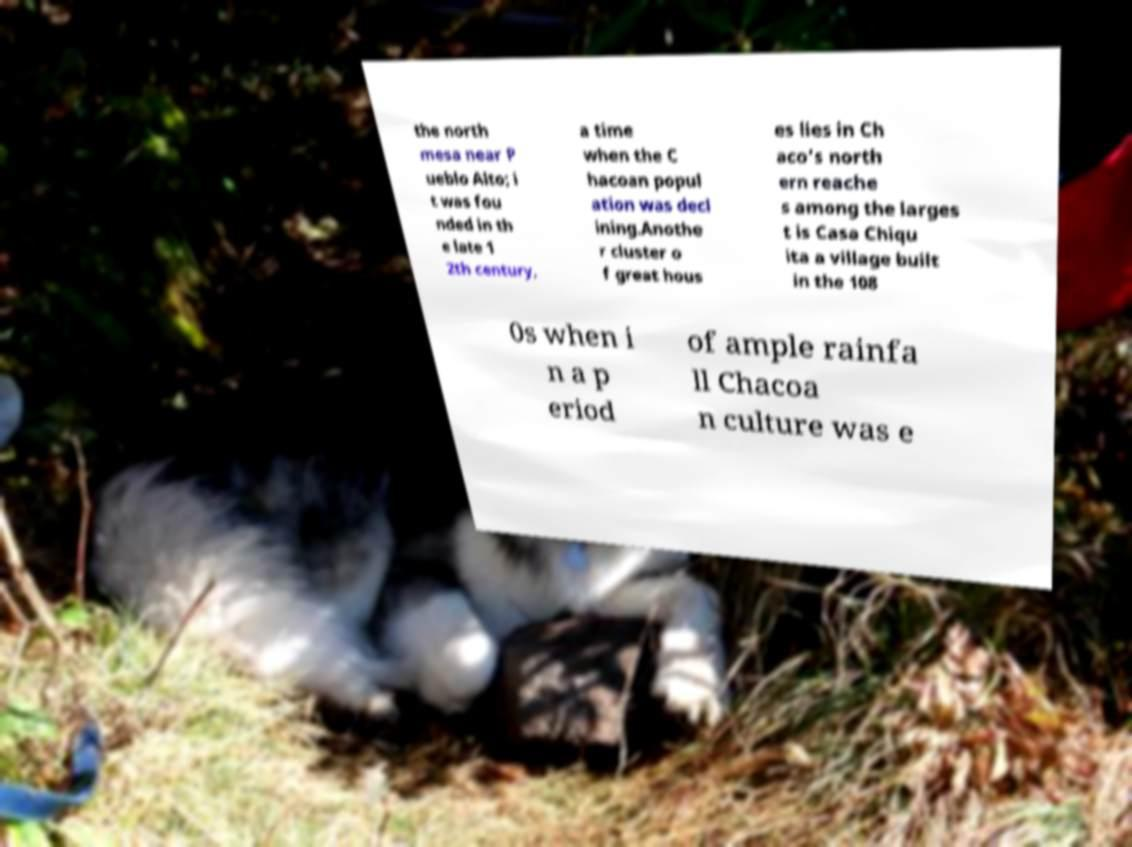Can you accurately transcribe the text from the provided image for me? the north mesa near P ueblo Alto; i t was fou nded in th e late 1 2th century, a time when the C hacoan popul ation was decl ining.Anothe r cluster o f great hous es lies in Ch aco's north ern reache s among the larges t is Casa Chiqu ita a village built in the 108 0s when i n a p eriod of ample rainfa ll Chacoa n culture was e 